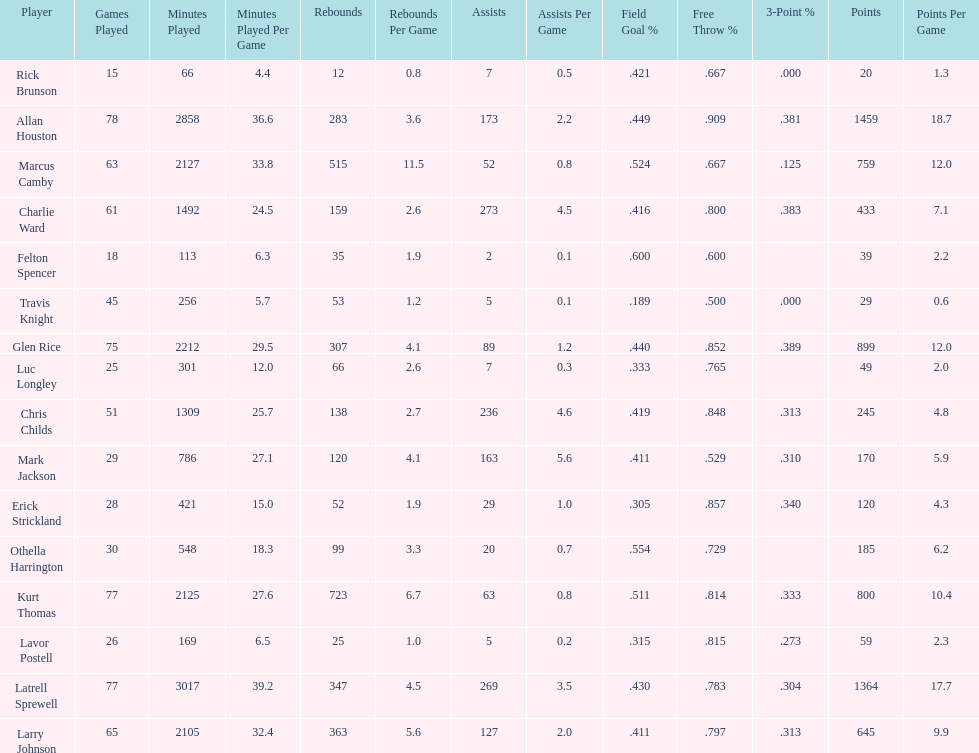How many more games did allan houston play than mark jackson? 49. 